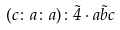<formula> <loc_0><loc_0><loc_500><loc_500>( c \colon a \colon a ) \colon \tilde { 4 } \cdot \tilde { a b c }</formula> 